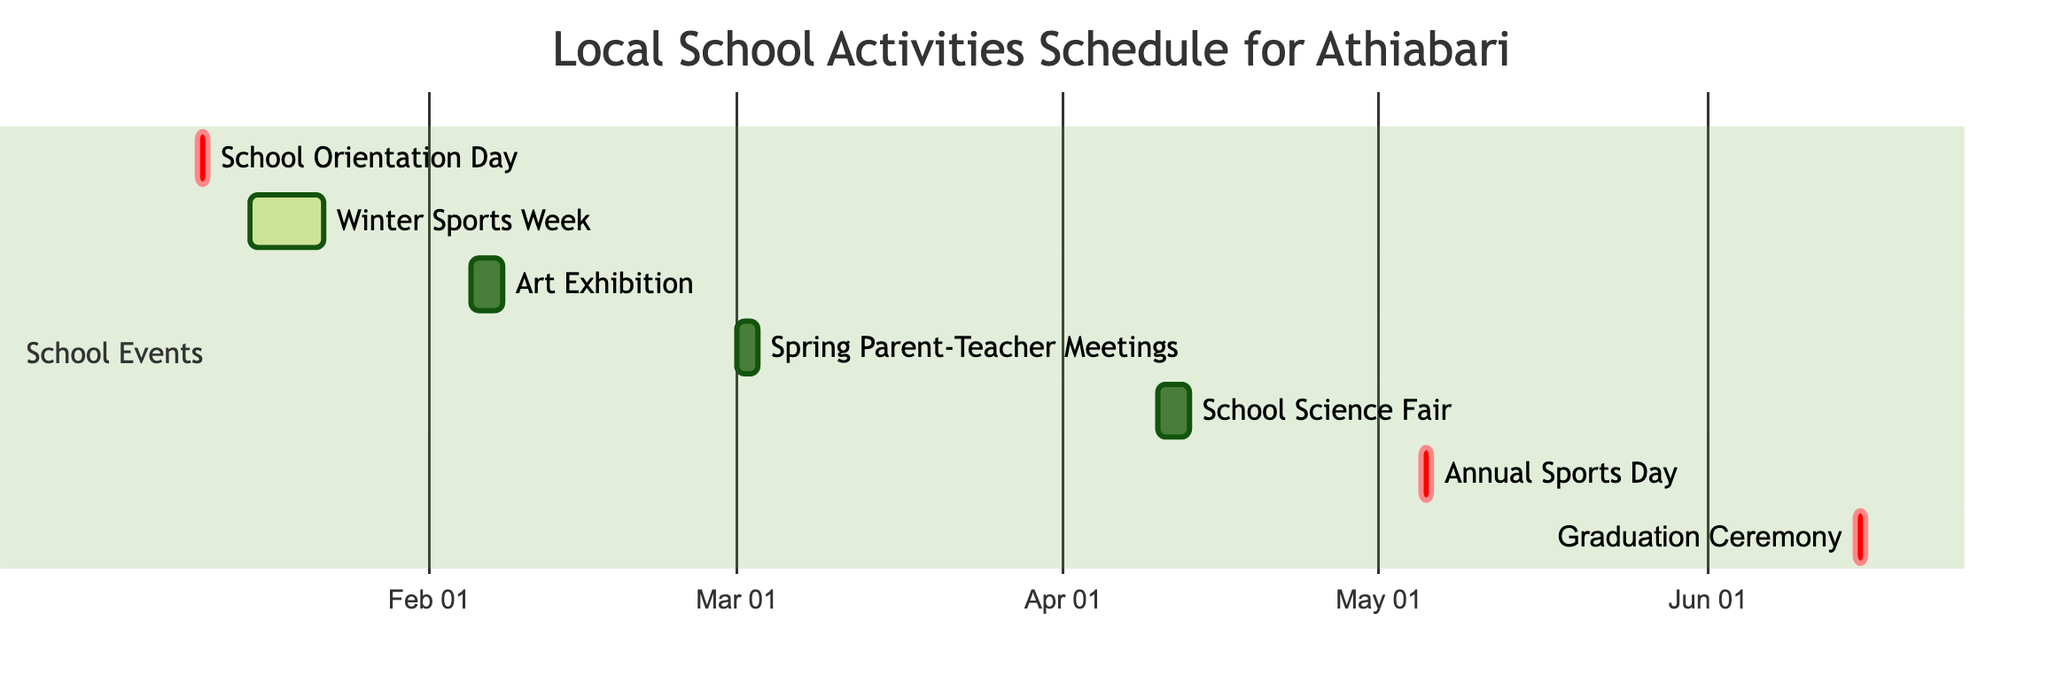What is the duration of the Winter Sports Week? The diagram indicates that Winter Sports Week lasts from January 15 to January 21, which is a total of 7 days.
Answer: 1 week How many activities are scheduled in March? Upon reviewing the Gantt chart, it shows two activities scheduled in March: Spring Parent-Teacher Meetings from March 1 to March 2 and another from March 3 to March 2, thus the total number is 2.
Answer: 2 Which activity occurs immediately after the School Orientation Day? The diagram displays that the School Orientation Day is on January 10, and the next activity, Winter Sports Week, starts on January 15, immediately after.
Answer: Winter Sports Week What is the start date of the Graduation Ceremony? Looking at the chart, the Graduation Ceremony is scheduled on June 15, 2024.
Answer: June 15 How long does the School Science Fair last? The Gantt chart indicates that the School Science Fair runs from April 10 to April 12, lasting a total of 3 days.
Answer: 3 days Which event has the longest duration? Comparing the durations of all activities on the Gantt chart, Winter Sports Week lasts for 7 days, which is the longest compared to the other events.
Answer: Winter Sports Week When is the Annual Sports Day scheduled? The diagram shows that the Annual Sports Day is scheduled for May 5, 2024.
Answer: May 5 How many single-day events are there in the schedule? Analyzing the chart, the events that last only 1 day are School Orientation Day, Annual Sports Day, and Graduation Ceremony. In total, there are 3 single-day events.
Answer: 3 What is the gap between the end of the Art Exhibition and the start of the Spring Parent-Teacher Meetings? The Art Exhibition ends on February 7, and the Spring Parent-Teacher Meetings begin on March 1, resulting in a gap of 21 days.
Answer: 21 days 